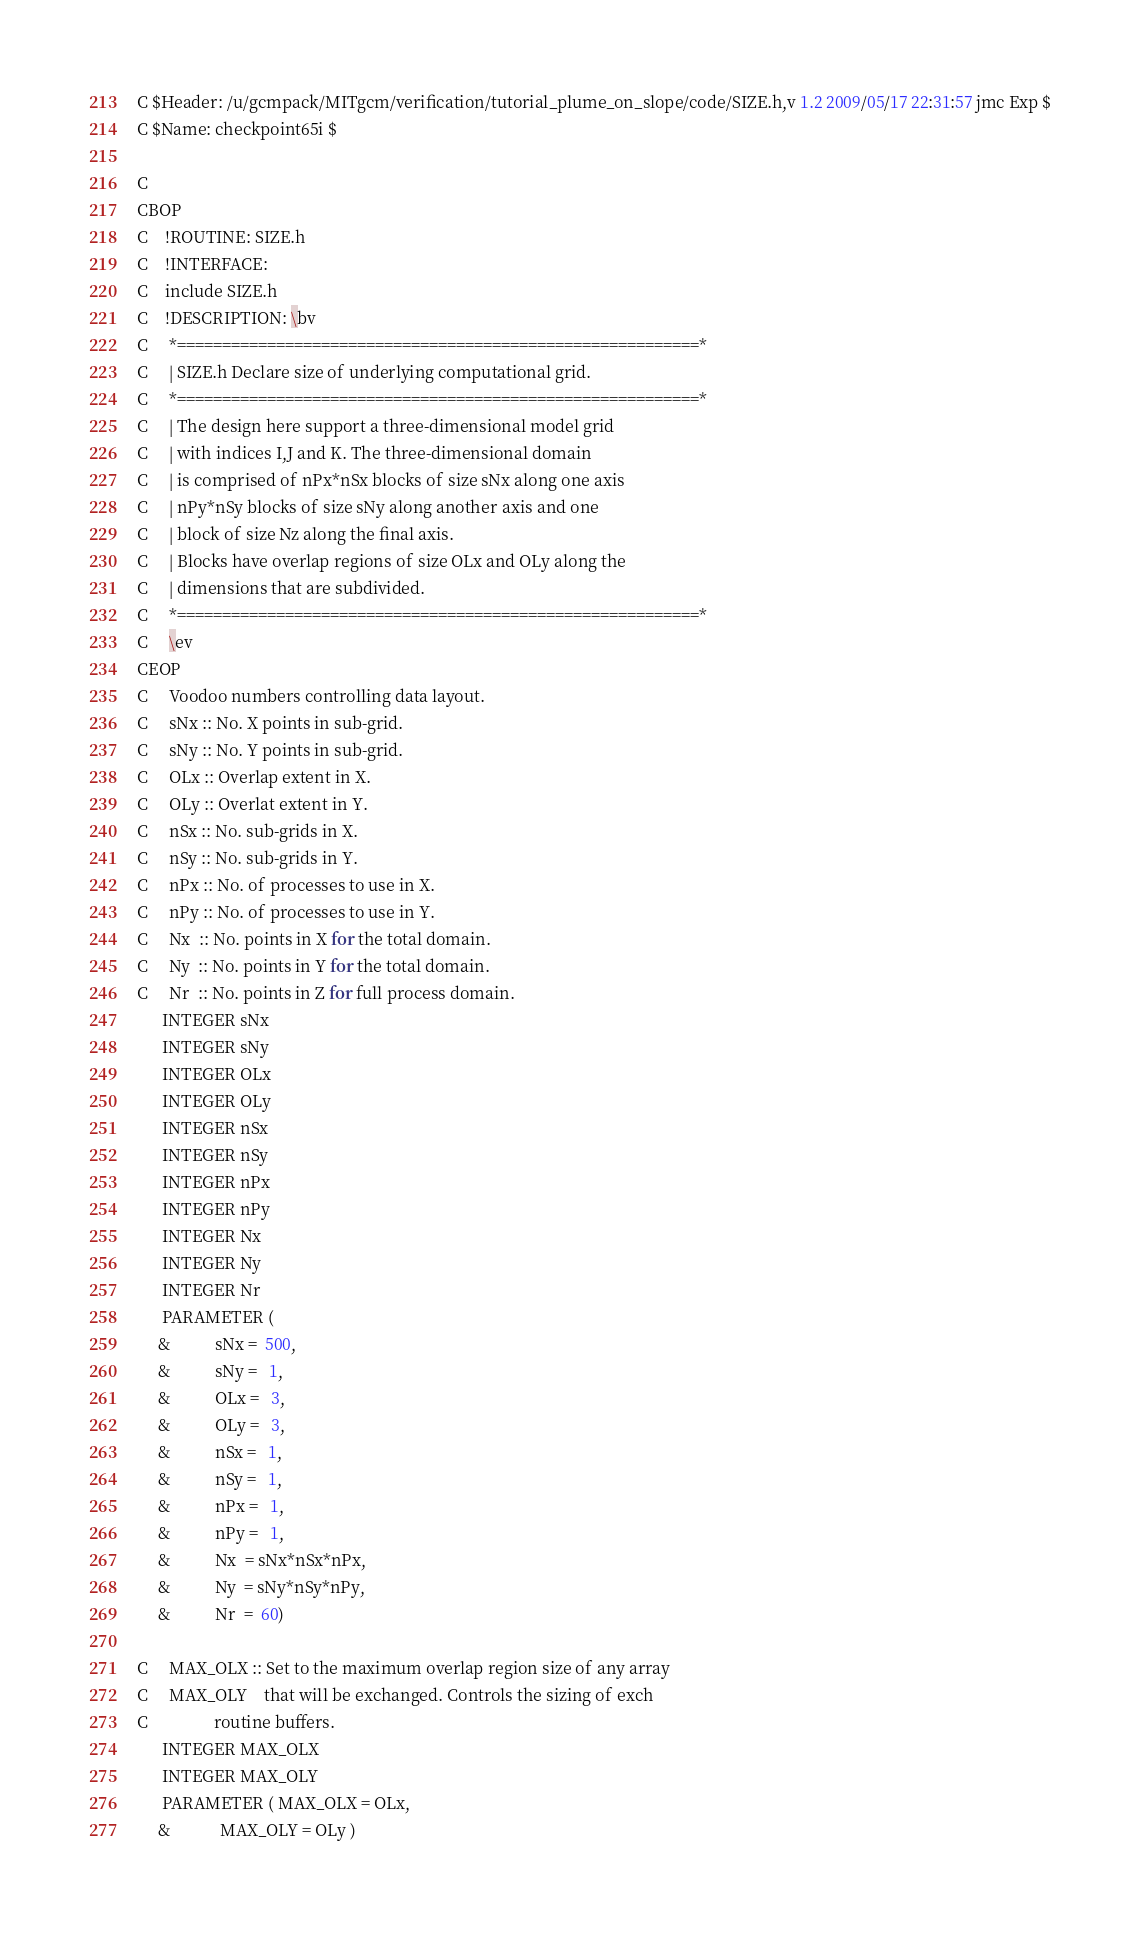<code> <loc_0><loc_0><loc_500><loc_500><_C_>C $Header: /u/gcmpack/MITgcm/verification/tutorial_plume_on_slope/code/SIZE.h,v 1.2 2009/05/17 22:31:57 jmc Exp $
C $Name: checkpoint65i $

C
CBOP
C    !ROUTINE: SIZE.h
C    !INTERFACE:
C    include SIZE.h
C    !DESCRIPTION: \bv
C     *==========================================================*
C     | SIZE.h Declare size of underlying computational grid.     
C     *==========================================================*
C     | The design here support a three-dimensional model grid    
C     | with indices I,J and K. The three-dimensional domain      
C     | is comprised of nPx*nSx blocks of size sNx along one axis 
C     | nPy*nSy blocks of size sNy along another axis and one     
C     | block of size Nz along the final axis.                    
C     | Blocks have overlap regions of size OLx and OLy along the 
C     | dimensions that are subdivided.                           
C     *==========================================================*
C     \ev
CEOP
C     Voodoo numbers controlling data layout.
C     sNx :: No. X points in sub-grid.
C     sNy :: No. Y points in sub-grid.
C     OLx :: Overlap extent in X.
C     OLy :: Overlat extent in Y.
C     nSx :: No. sub-grids in X.
C     nSy :: No. sub-grids in Y.
C     nPx :: No. of processes to use in X.
C     nPy :: No. of processes to use in Y.
C     Nx  :: No. points in X for the total domain.
C     Ny  :: No. points in Y for the total domain.
C     Nr  :: No. points in Z for full process domain.
      INTEGER sNx
      INTEGER sNy
      INTEGER OLx
      INTEGER OLy
      INTEGER nSx
      INTEGER nSy
      INTEGER nPx
      INTEGER nPy
      INTEGER Nx
      INTEGER Ny
      INTEGER Nr
      PARAMETER (
     &           sNx =  500,
     &           sNy =   1,
     &           OLx =   3,
     &           OLy =   3,
     &           nSx =   1,
     &           nSy =   1,
     &           nPx =   1,
     &           nPy =   1,
     &           Nx  = sNx*nSx*nPx,
     &           Ny  = sNy*nSy*nPy,
     &           Nr  =  60)

C     MAX_OLX :: Set to the maximum overlap region size of any array
C     MAX_OLY    that will be exchanged. Controls the sizing of exch
C                routine buffers.
      INTEGER MAX_OLX
      INTEGER MAX_OLY
      PARAMETER ( MAX_OLX = OLx,
     &            MAX_OLY = OLy )

</code> 